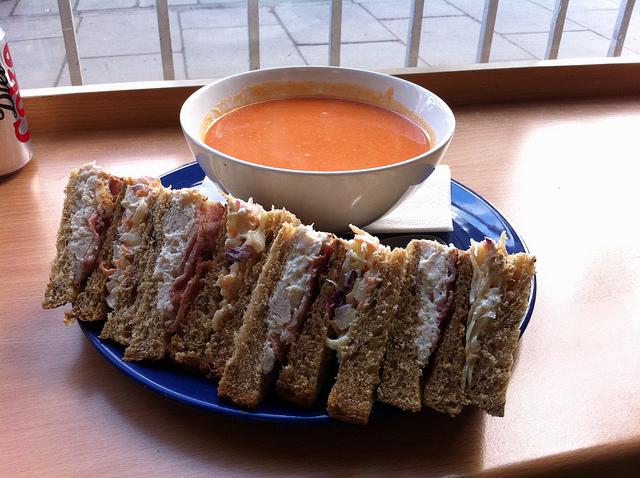What kind of food is this?
Write a very short answer. Sandwich and soup. What color is the soup?
Give a very brief answer. Red. Is the plate on top of a table?
Keep it brief. Yes. 